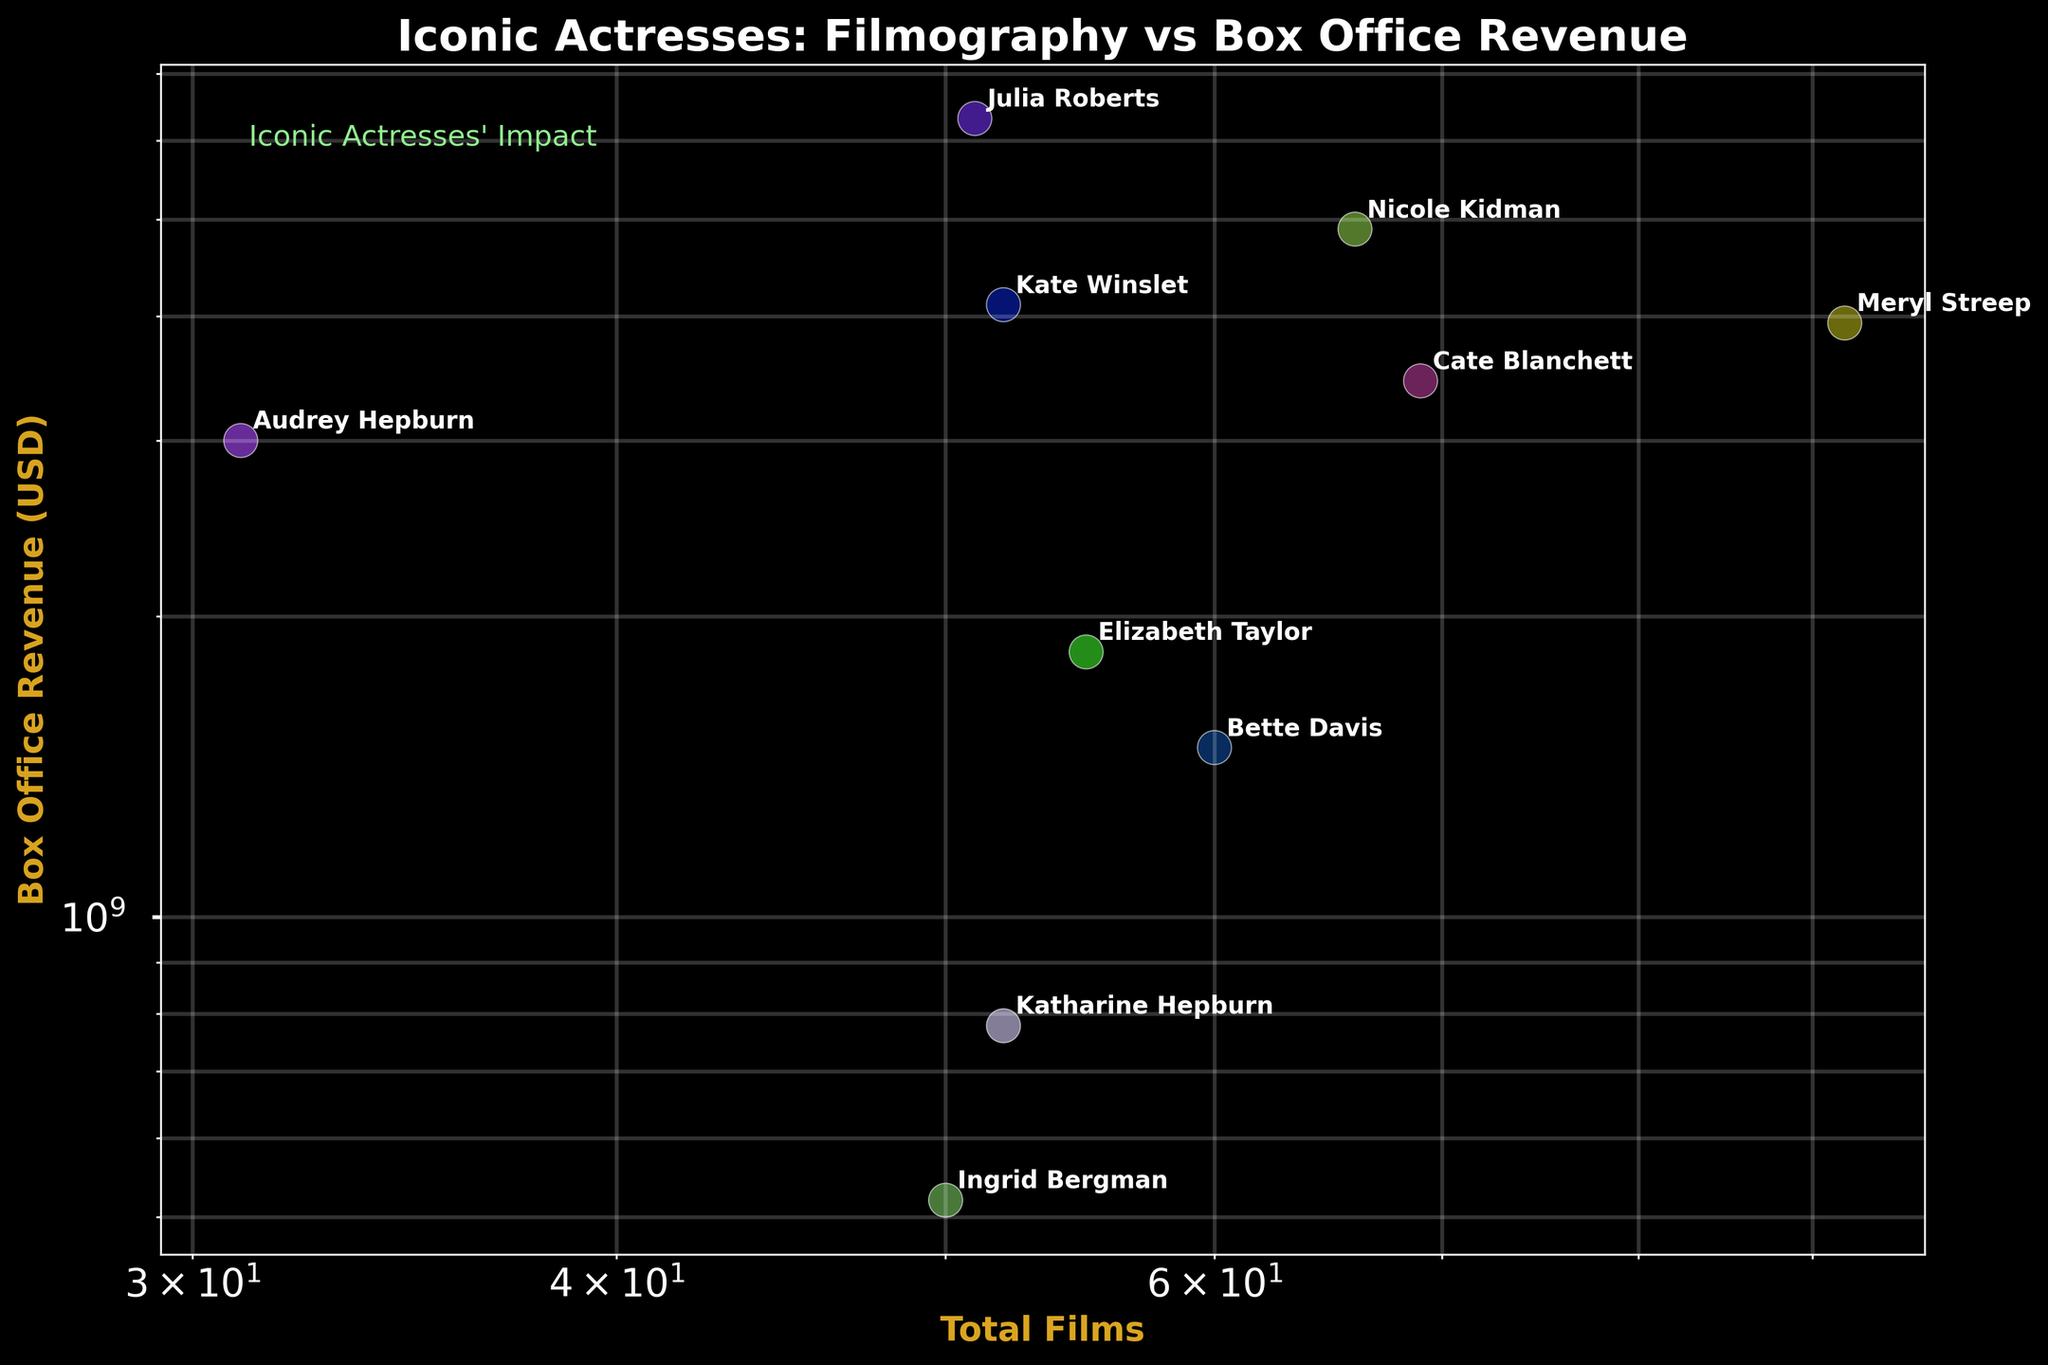What's the title of the plot? The title is located at the top of the figure. It reads "Iconic Actresses: Filmography vs Box Office Revenue".
Answer: Iconic Actresses: Filmography vs Box Office Revenue Which actress has the highest box office revenue? By observing the y-axis, the highest box office revenue among the actresses listed can be identified. Julia Roberts is at the topmost position in terms of revenue.
Answer: Julia Roberts Which actress has appeared in the most films? Look along the x-axis to find the actress with the highest value of total films. This is Meryl Streep with 92 films.
Answer: Meryl Streep What is the range of total films acted in by the actresses? The x-axis shows total films on a log scale. The range can be identified by the minimum and maximum values. The minimum is 31 (Audrey Hepburn) and the maximum is 92 (Meryl Streep).
Answer: 31 to 92 Who has a greater total film count, Katharine Hepburn or Nicole Kidman? Locate both actresses on the x-axis and compare their positions. Katharine Hepburn has fewer total films than Nicole Kidman.
Answer: Nicole Kidman What’s the difference in box office revenue between Meryl Streep and Cate Blanchett? Find Meryl Streep and Cate Blanchett on the y-axis. Subtract Cate Blanchett’s revenue from Meryl Streep’s revenue: $3937M - $3445M.
Answer: $492 million Which two actresses have the closest box office revenues? Compare the positions along the y-axis and identify the two actresses whose vertical positions are nearest. Meryl Streep and Kate Winslet have close box office revenues.
Answer: Meryl Streep and Kate Winslet What's the average box office revenue of the actresses? Sum all the box office revenues and divide by the number of actresses (10): (3937 + 777.8 + 520 + 3002 + 1478 + 1843 + 4890 + 3445 + 4107 + 6312) million divided by 10.
Answer: Approximately $3021 million Which actress has a greater income per film, Meryl Streep or Audrey Hepburn? Calculate income per film for both: Meryl Streep ($3937M/92 films ≈ $42.8M per film) and Audrey Hepburn ($3002M/31 films ≈ $96.8M per film). Audrey Hepburn has a higher income per film.
Answer: Audrey Hepburn Are there more actresses with total films greater than 50 or fewer than 50? Count the number of actresses with total films greater than 50 (Meryl Streep, Bette Davis, Elizabeth Taylor, Nicole Kidman, Cate Blanchett, and Kate Winslet) which is 6, and fewer than 50 (Katharine Hepburn, Ingrid Bergman, Audrey Hepburn, Julia Roberts) which is 4.
Answer: Greater than 50 